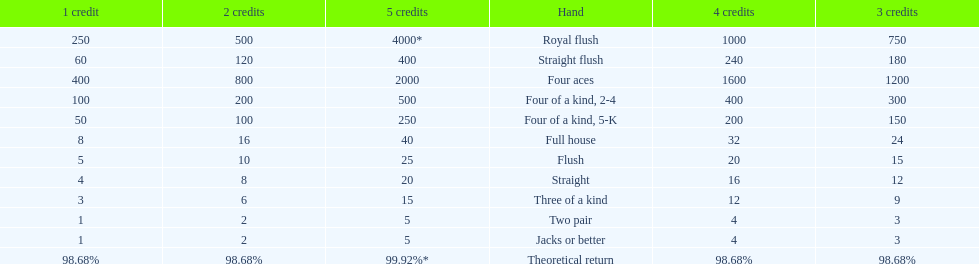What is the difference of payout on 3 credits, between a straight flush and royal flush? 570. 